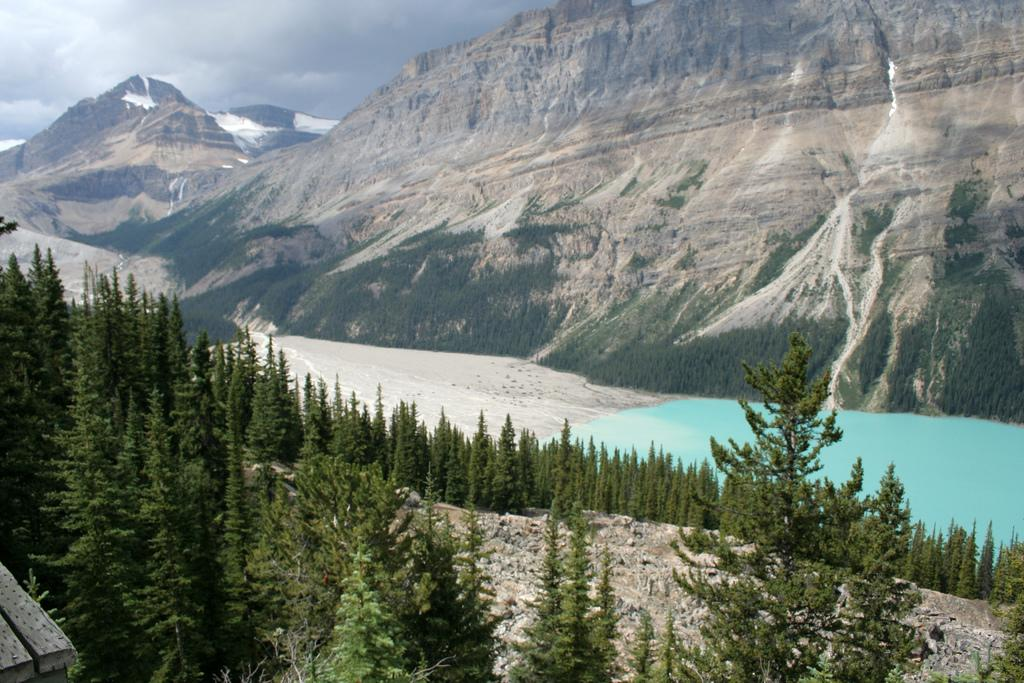What type of natural features can be seen in the image? There are trees, stones, mountains, and water visible in the image. What is the condition of the sky in the image? The sky is visible in the image, and there are clouds present. What is the primary source of water in the image? The water visible in the image is likely a river or lake. What type of bell can be heard ringing in the image? There is no bell present in the image, and therefore no sound can be heard. How many cats are visible in the image? There are no cats present in the image. 